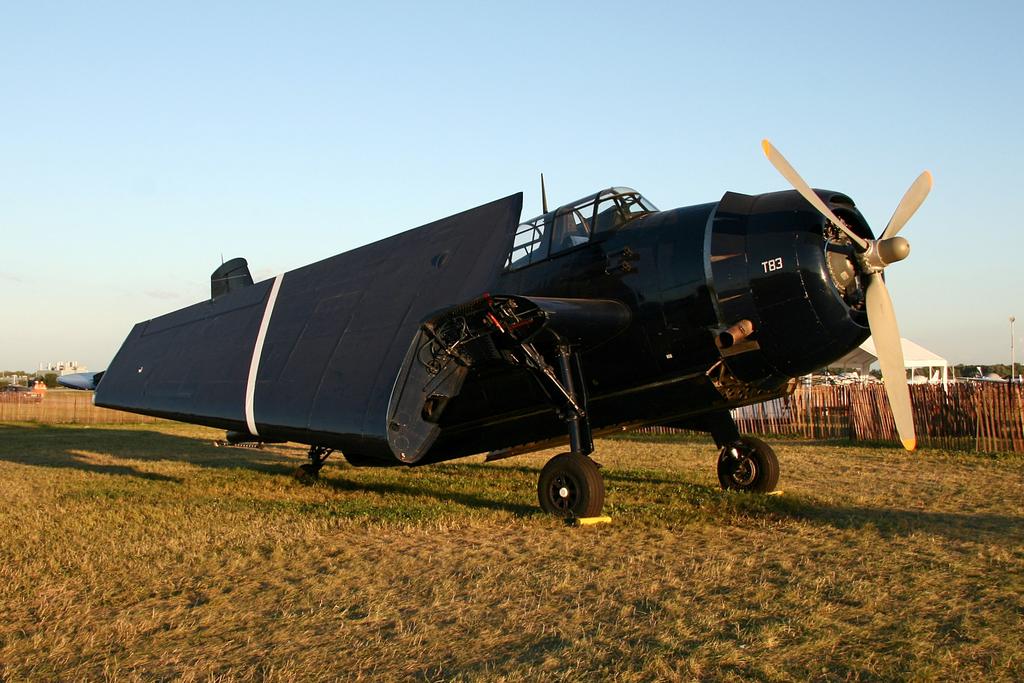What numbers are on the front?
Provide a short and direct response. T83. 